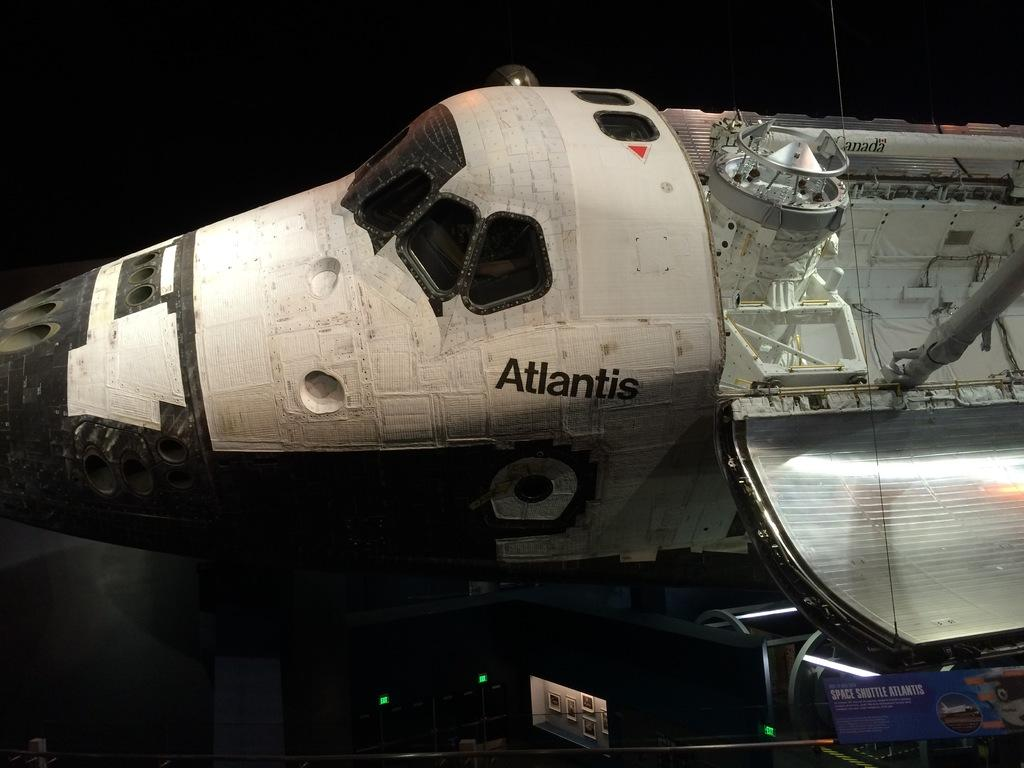<image>
Give a short and clear explanation of the subsequent image. An atlantis space craft shuttled being dissasembled and it's inner workings shown. 